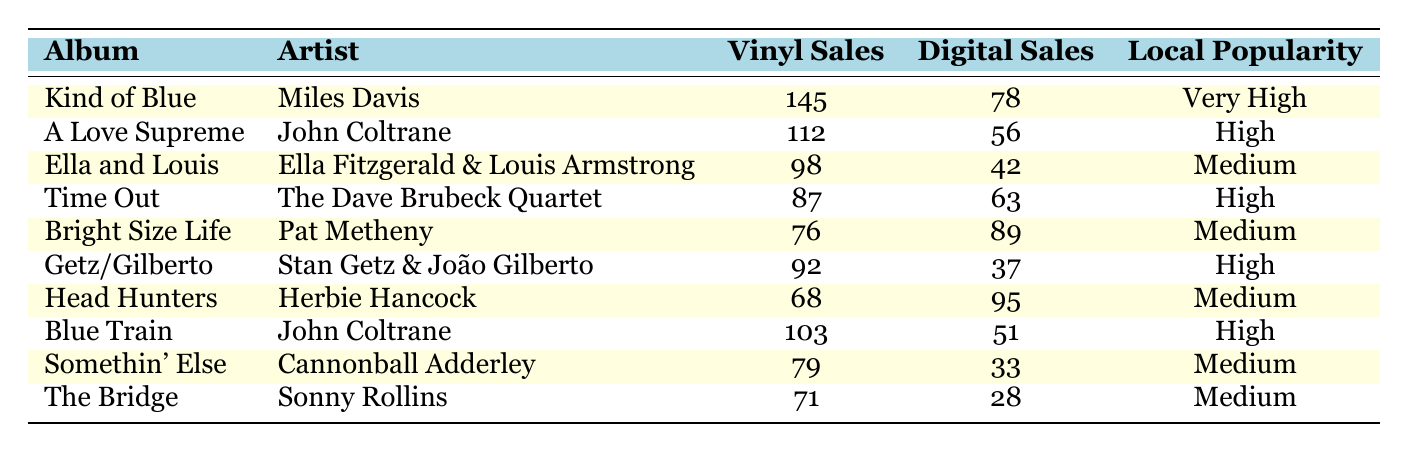What is the vinyl sales number for "Kind of Blue"? The table lists the album "Kind of Blue" under the Vinyl Sales column, which shows a value of 145.
Answer: 145 Which album has the highest digital sales? By checking the Digital Sales column, "Head Hunters" has the highest sales number of 95, which is greater than the other albums.
Answer: Head Hunters Is "Ella and Louis" more popular in vinyl sales than "Getz/Gilberto"? Checking the Vinyl Sales, "Ella and Louis" has 98 sales and "Getz/Gilberto" has 92 sales. Since 98 is greater than 92, the statement is true.
Answer: Yes What is the total number of vinyl sales for albums categorized as "High" in local popularity? The albums with "High" local popularity are "A Love Supreme", "Time Out", and "Getz/Gilberto". Their vinyl sales are 112, 87, and 92 respectively. The total is 112 + 87 + 92 = 291.
Answer: 291 How many more vinyl sales does "Blue Train" have compared to "The Bridge"? For "Blue Train", the Vinyl Sales are 103 and for "The Bridge", it's 71. The difference is 103 - 71 = 32.
Answer: 32 What is the average digital sales of albums with "Medium" local popularity? The "Medium" local popularity albums are "Ella and Louis", "Bright Size Life", "Head Hunters", "Somethin' Else", and "The Bridge". Their digital sales are 42, 89, 95, 33, and 28 respectively. The total sales is 42 + 89 + 95 + 33 + 28 = 287. The average is 287 / 5 = 57.4.
Answer: 57.4 Is it true that "Bright Size Life" has more digital sales than "A Love Supreme"? Comparing the digital sales, "Bright Size Life" has 89 and "A Love Supreme" has 56. Since 89 is greater than 56, the statement is true.
Answer: Yes Which artist has the most albums listed in this table? On inspecting the table, "John Coltrane" appears with two albums: "A Love Supreme" and "Blue Train". All other artists have only one album listed.
Answer: John Coltrane 